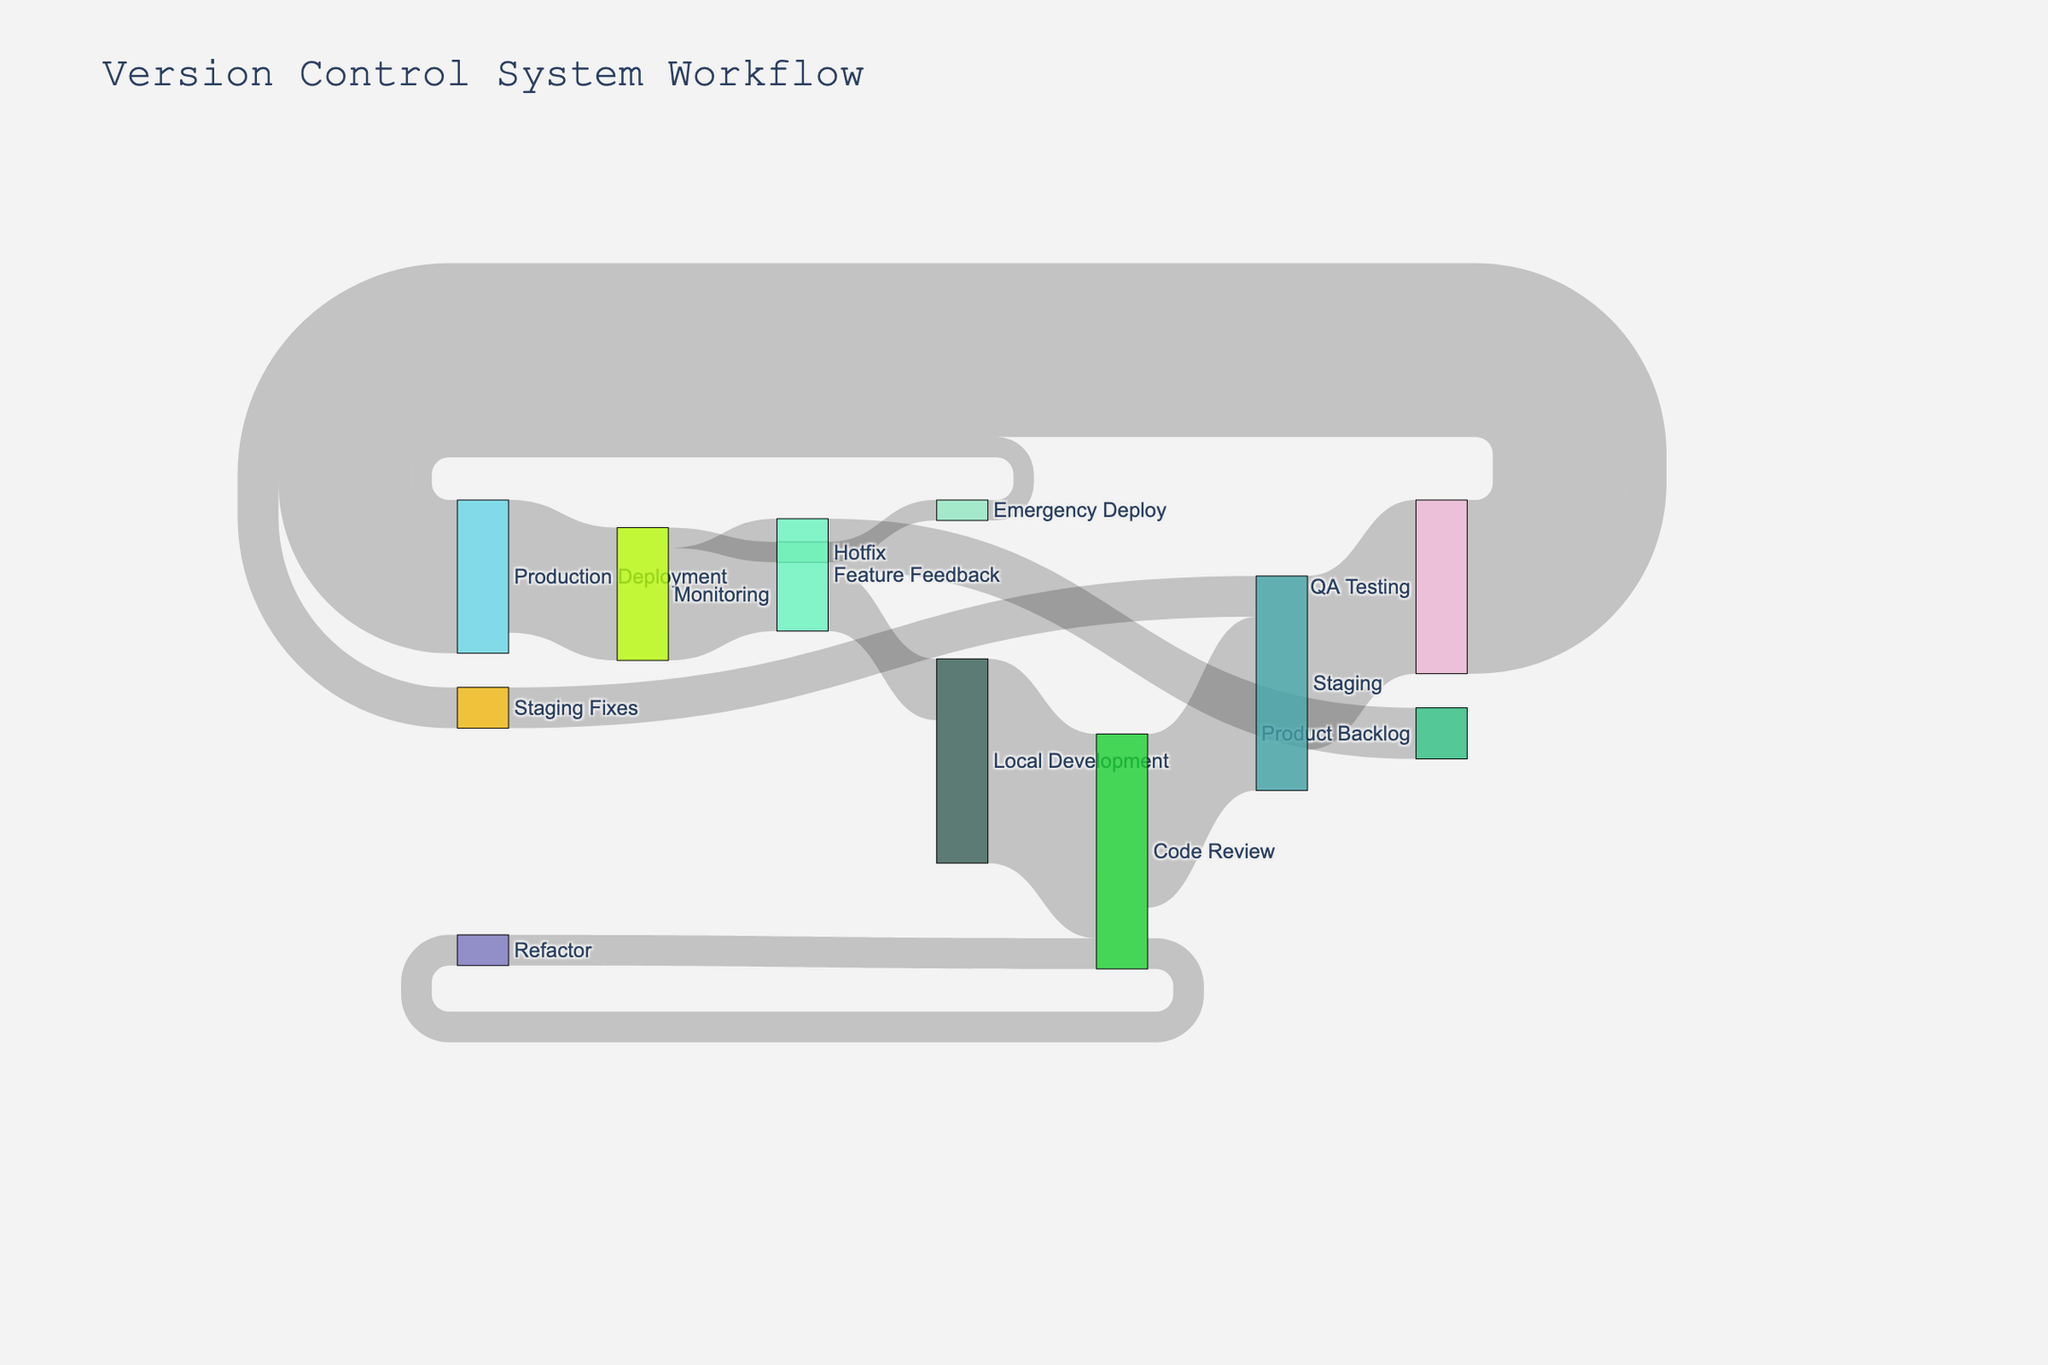What's the total number of changes that reach Production Deployment? To determine this, observe the links going to 'Production Deployment.' There are 65 changes from 'QA Testing' and 10 from 'Emergency Deploy.' Adding these up gives 65 + 10 = 75.
Answer: 75 Which step receives the most code changes initially from Local Development? Look at the link originating from 'Local Development.' It shows that 'Code Review' gets 100 changes, which is the only target of direct flow from 'Local Development.' Therefore, 'Code Review' receives the most.
Answer: Code Review How many changes are made after QA Testing before reaching Staging again? To find this, identify the path through 'QA Testing.' From 'QA Testing,' 20 changes go to 'Staging Fixes,' which then moves back to 'Staging.' Thus, 20 changes are made post-QA Testing before returning to Staging.
Answer: 20 Which node has the highest number of outgoing changes from Monitoring? Observe the outgoing links from 'Monitoring.' There are 10 changes to 'Hotfix' and 55 to 'Feature Feedback.' Comparing these, 'Feature Feedback' has the highest number of outgoing changes with 55.
Answer: Feature Feedback How many changes never make it to Production Deployment after the initial 'Code Review'? From 'Code Review,' changes are divided into 'Staging' (85) and 'Refactor' (15). The 15 changes going through 'Refactor' don't directly contribute to 'Production Deployment.' Hence, 15 changes do not make it to production.
Answer: 15 What is the total number of changes that loop back to 'Code Review'? Check for loops involving 'Code Review.' 'Refactor' has 15 changes that go back to 'Code Review.' Since no other node flows back to 'Code Review,' the total is 15.
Answer: 15 What happens to code changes after 'Feature Feedback'? Observing 'Feature Feedback,' changes split into 'Local Development' (30) and 'Product Backlog' (25). These are the only two flows, so 30 changes go back to development and 25 go to the backlog.
Answer: 30 to Local Development and 25 to Product Backlog How many changes make it through to 'QA Testing' from 'Local Development'? Follow the path from 'Local Development' to 'QA Testing': First, 100 changes go to 'Code Review,' 85 move to 'Staging,' and all 85 proceed to 'QA Testing.' Therefore, 85 changes from 'Local Development' reach 'QA Testing.'
Answer: 85 By how much do the changes decrease from 'Code Review' to 'Production Deployment'? From 'Code Review,' 85 changes go to 'Staging' and proceed to 'QA Testing,' then 65 move to 'Production Deployment.' Calculation: Initial (85) - Final (65) = 20. Hence, changes decrease by 20.
Answer: 20 